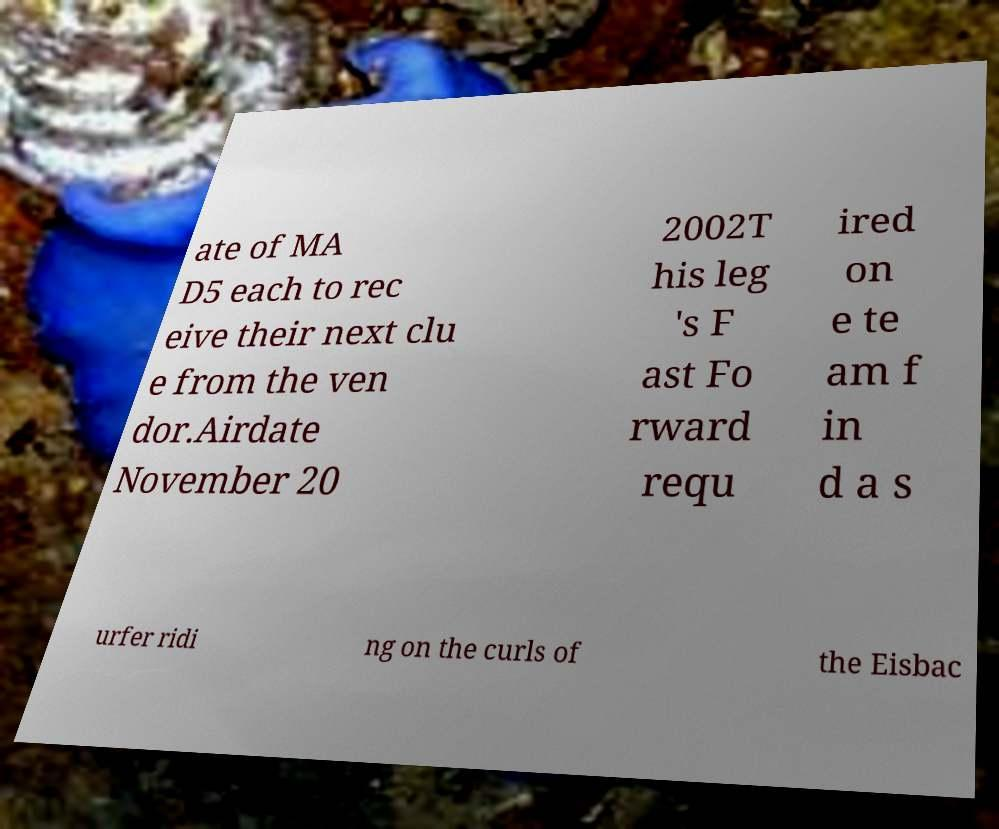For documentation purposes, I need the text within this image transcribed. Could you provide that? ate of MA D5 each to rec eive their next clu e from the ven dor.Airdate November 20 2002T his leg 's F ast Fo rward requ ired on e te am f in d a s urfer ridi ng on the curls of the Eisbac 